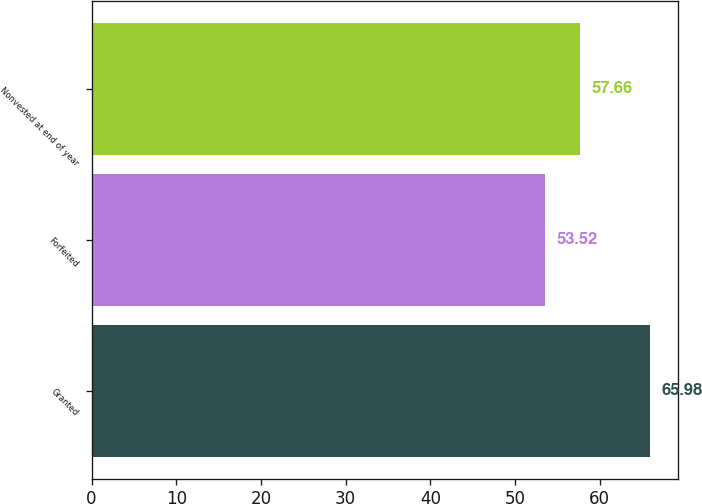<chart> <loc_0><loc_0><loc_500><loc_500><bar_chart><fcel>Granted<fcel>Forfeited<fcel>Nonvested at end of year<nl><fcel>65.98<fcel>53.52<fcel>57.66<nl></chart> 